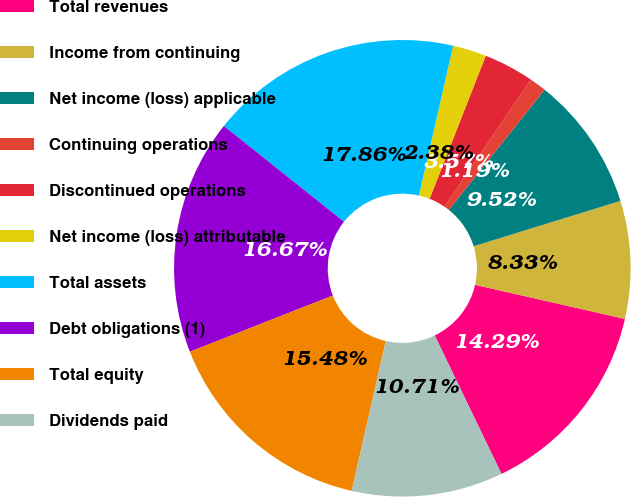Convert chart. <chart><loc_0><loc_0><loc_500><loc_500><pie_chart><fcel>Total revenues<fcel>Income from continuing<fcel>Net income (loss) applicable<fcel>Continuing operations<fcel>Discontinued operations<fcel>Net income (loss) attributable<fcel>Total assets<fcel>Debt obligations (1)<fcel>Total equity<fcel>Dividends paid<nl><fcel>14.29%<fcel>8.33%<fcel>9.52%<fcel>1.19%<fcel>3.57%<fcel>2.38%<fcel>17.86%<fcel>16.67%<fcel>15.48%<fcel>10.71%<nl></chart> 